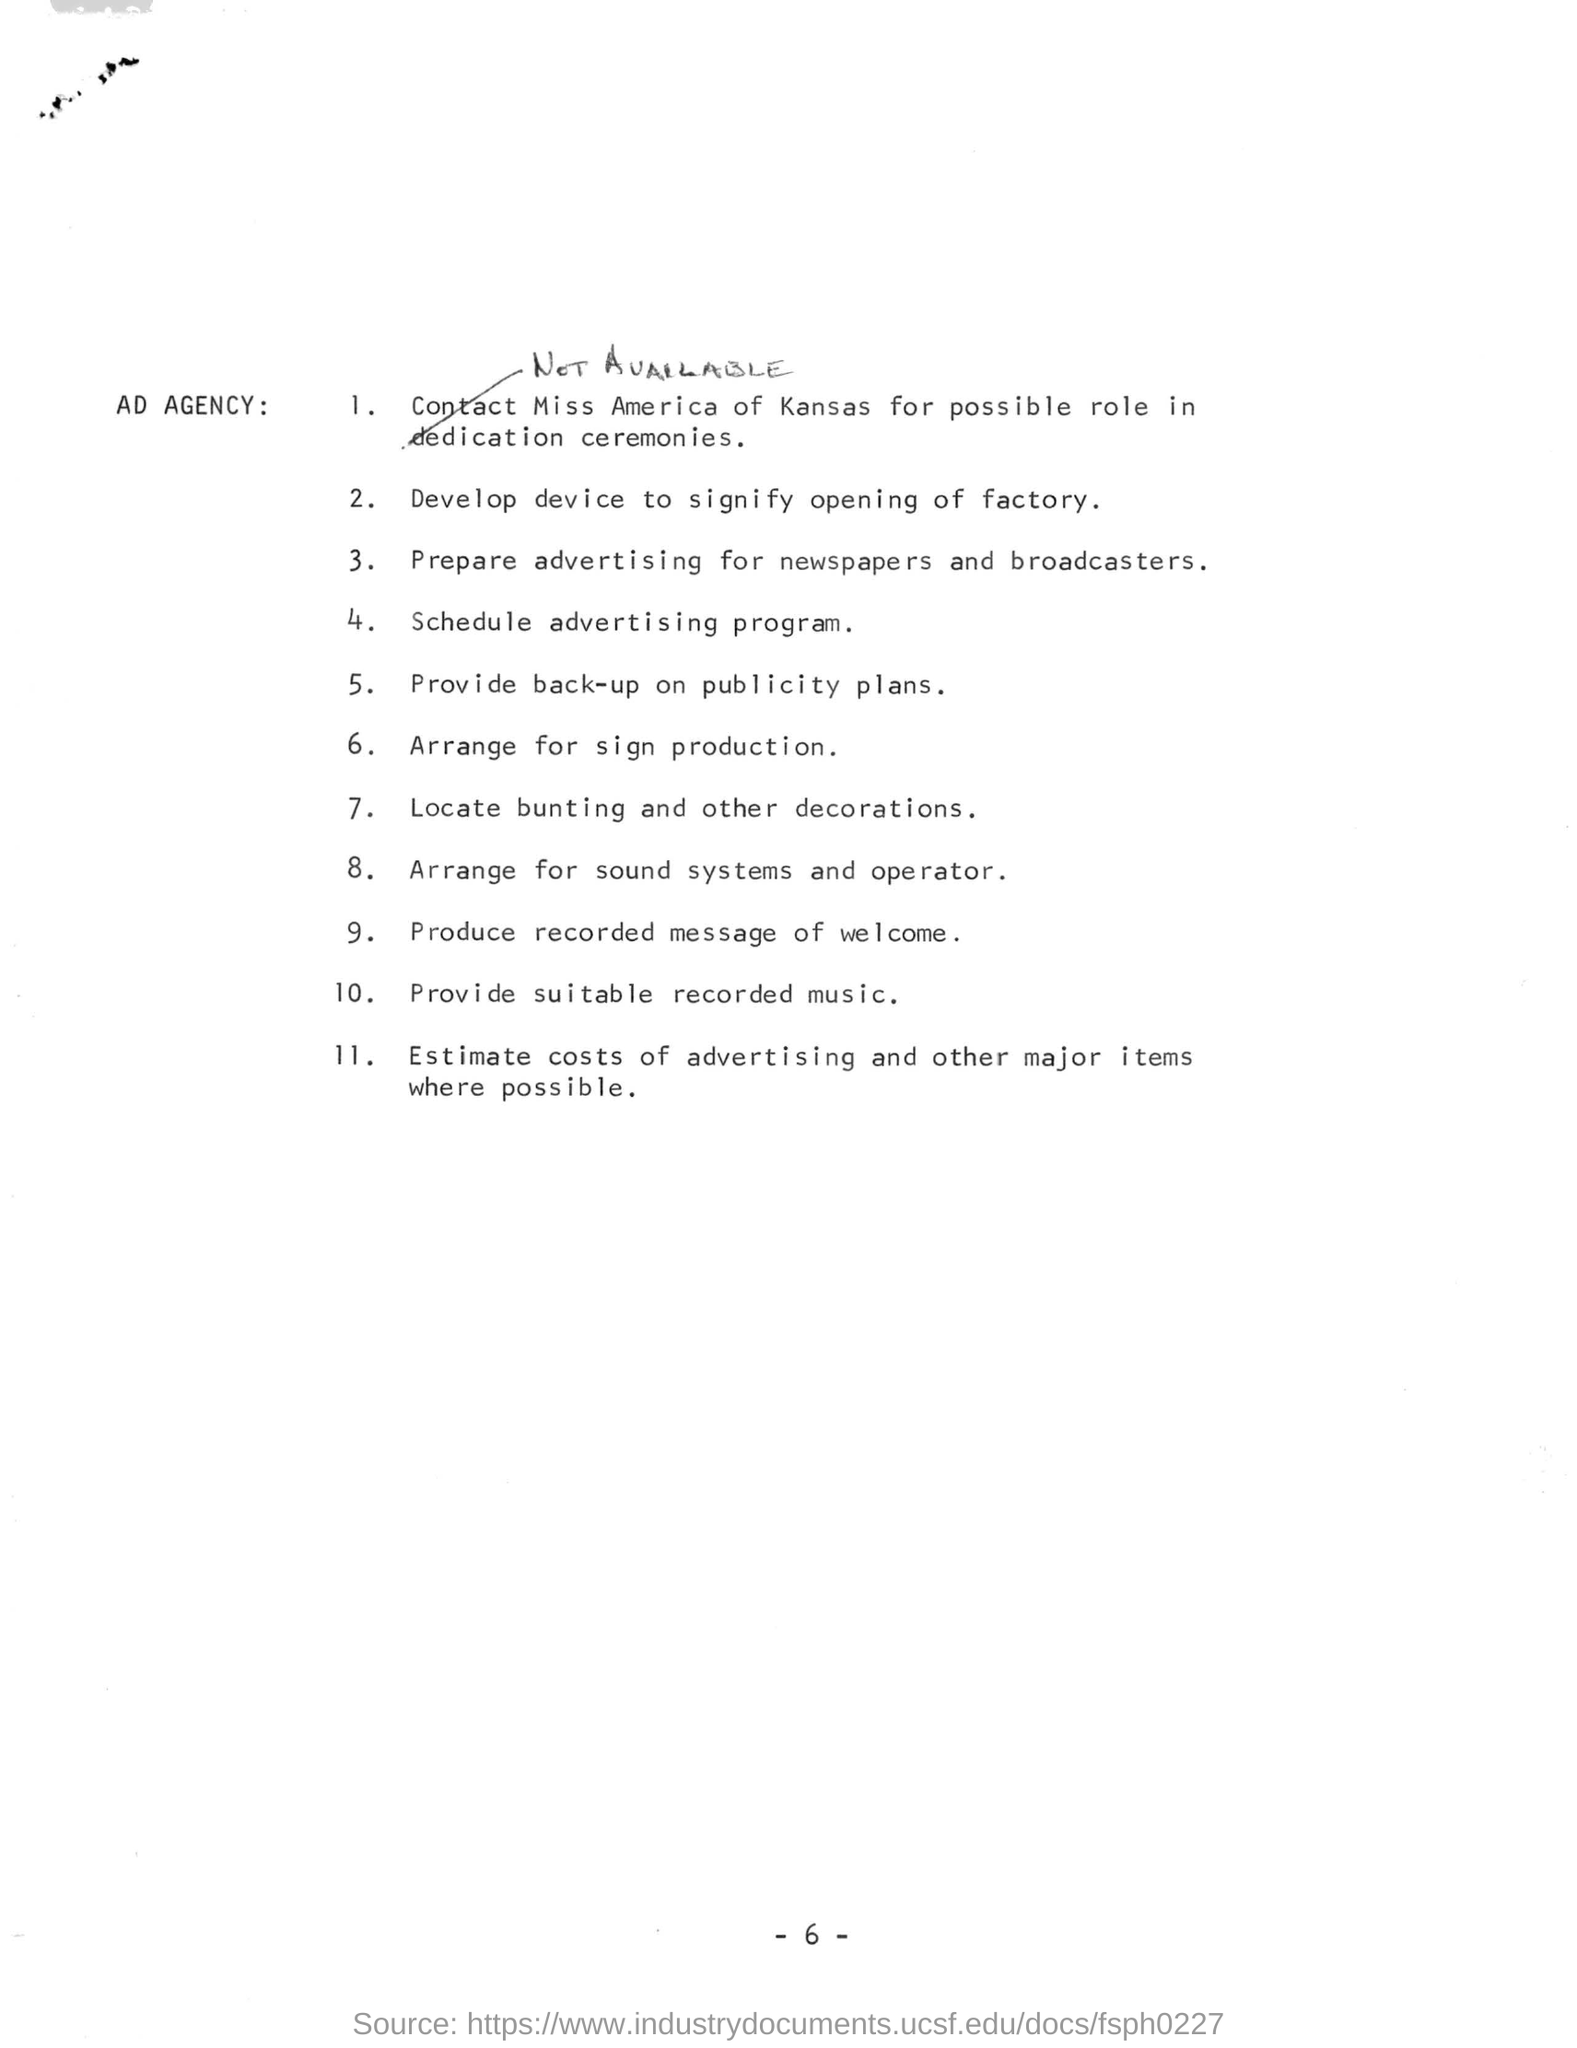How many points are there in the checklist?
Keep it short and to the point. 11. What is point 10. in this list?
Keep it short and to the point. Provide suitable recorded music. Who has to be contacted for role in dedication ceremonies?
Keep it short and to the point. Miss America of Kansas. 